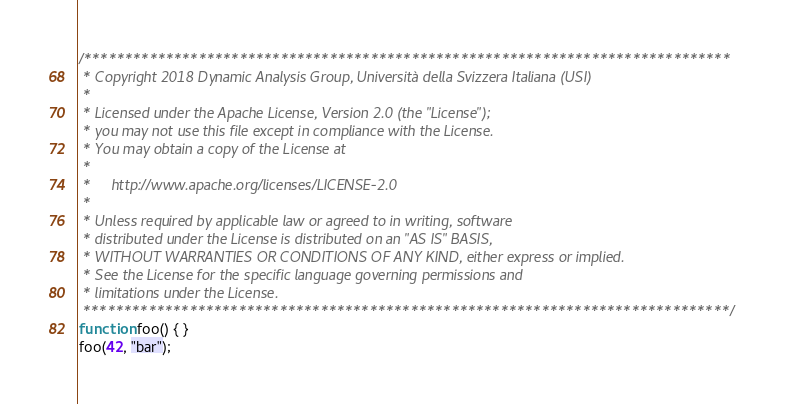<code> <loc_0><loc_0><loc_500><loc_500><_JavaScript_>/*******************************************************************************
 * Copyright 2018 Dynamic Analysis Group, Università della Svizzera Italiana (USI)
 *
 * Licensed under the Apache License, Version 2.0 (the "License");
 * you may not use this file except in compliance with the License.
 * You may obtain a copy of the License at
 *
 *     http://www.apache.org/licenses/LICENSE-2.0
 *
 * Unless required by applicable law or agreed to in writing, software
 * distributed under the License is distributed on an "AS IS" BASIS,
 * WITHOUT WARRANTIES OR CONDITIONS OF ANY KIND, either express or implied.
 * See the License for the specific language governing permissions and
 * limitations under the License.
 *******************************************************************************/
function foo() { }
foo(42, "bar");
</code> 